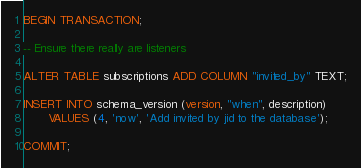Convert code to text. <code><loc_0><loc_0><loc_500><loc_500><_SQL_>BEGIN TRANSACTION;

-- Ensure there really are listeners

ALTER TABLE subscriptions ADD COLUMN "invited_by" TEXT;

INSERT INTO schema_version (version, "when", description)
       VALUES (4, 'now', 'Add invited by jid to the database');

COMMIT;
</code> 